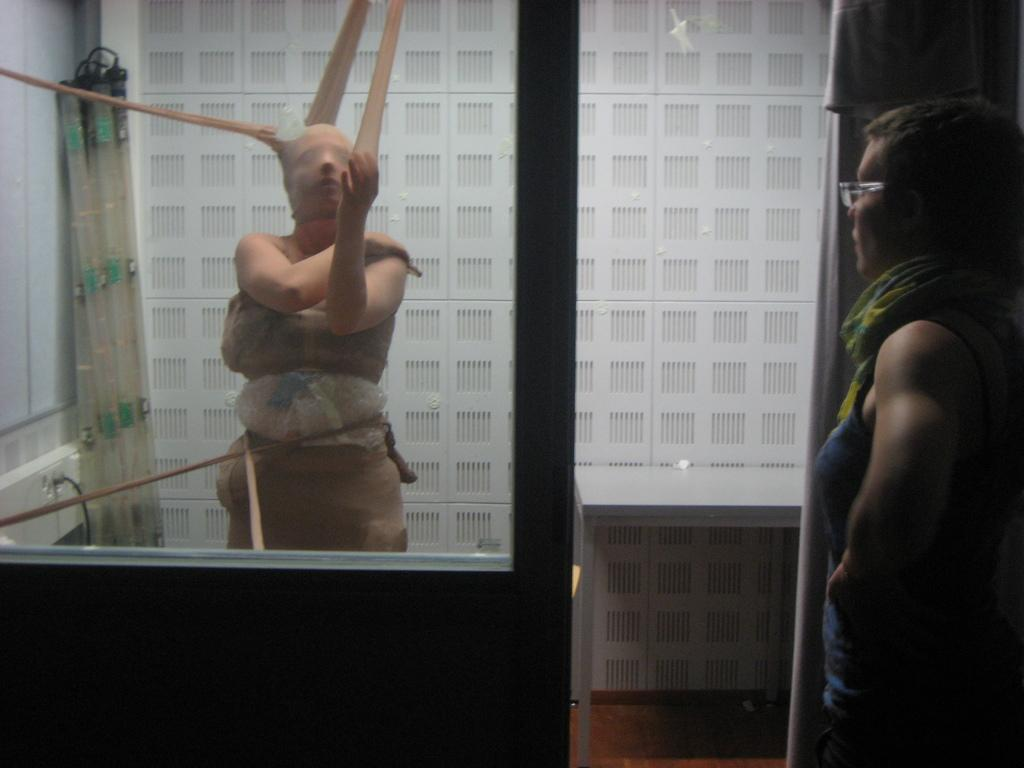What is the person in the image carrying on their body? The person in the image has clothes and things tied to them. Can you describe the appearance of the other person in the image? The other person is wearing spectacles. What can be seen in the background of the image? There is a white wall in the background of the image. How many trees can be seen in the image? There are no trees visible in the image; it features two people and a white wall in the background. 